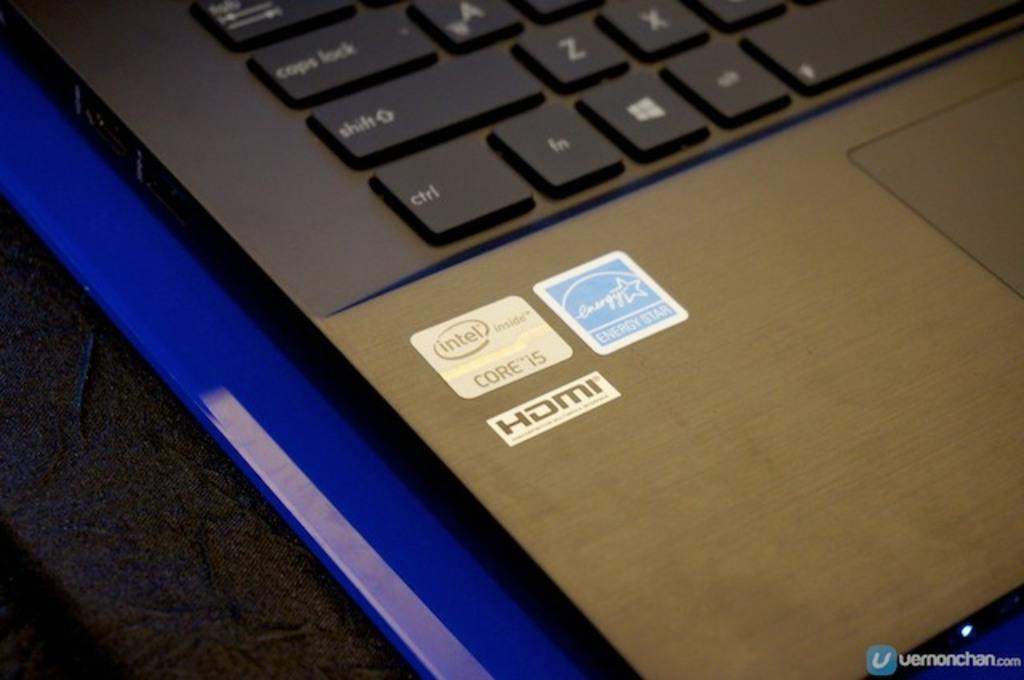<image>
Provide a brief description of the given image. a close up of a computer with stickers reading HDMI 